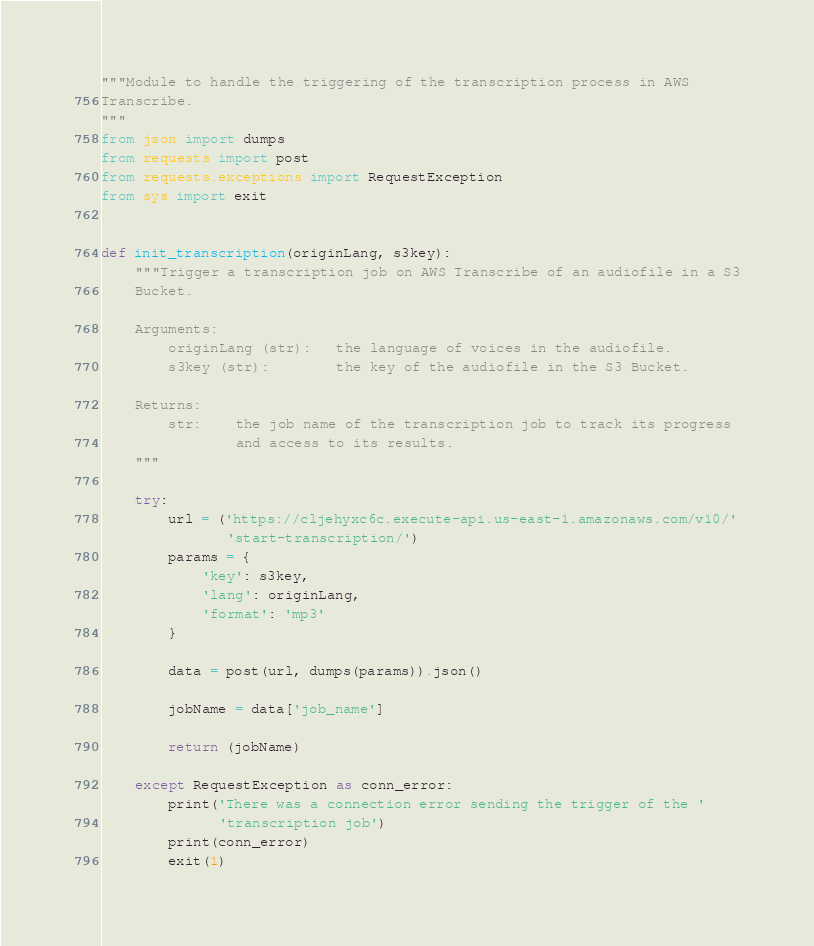Convert code to text. <code><loc_0><loc_0><loc_500><loc_500><_Python_>"""Module to handle the triggering of the transcription process in AWS
Transcribe.
"""
from json import dumps
from requests import post
from requests.exceptions import RequestException
from sys import exit


def init_transcription(originLang, s3key):
    """Trigger a transcription job on AWS Transcribe of an audiofile in a S3
    Bucket.

    Arguments:
        originLang (str):   the language of voices in the audiofile.
        s3key (str):        the key of the audiofile in the S3 Bucket.

    Returns:
        str:    the job name of the transcription job to track its progress
                and access to its results.
    """

    try:
        url = ('https://cljehyxc6c.execute-api.us-east-1.amazonaws.com/v10/'
               'start-transcription/')
        params = {
            'key': s3key,
            'lang': originLang,
            'format': 'mp3'
        }

        data = post(url, dumps(params)).json()

        jobName = data['job_name']

        return (jobName)

    except RequestException as conn_error:
        print('There was a connection error sending the trigger of the '
              'transcription job')
        print(conn_error)
        exit(1)
</code> 